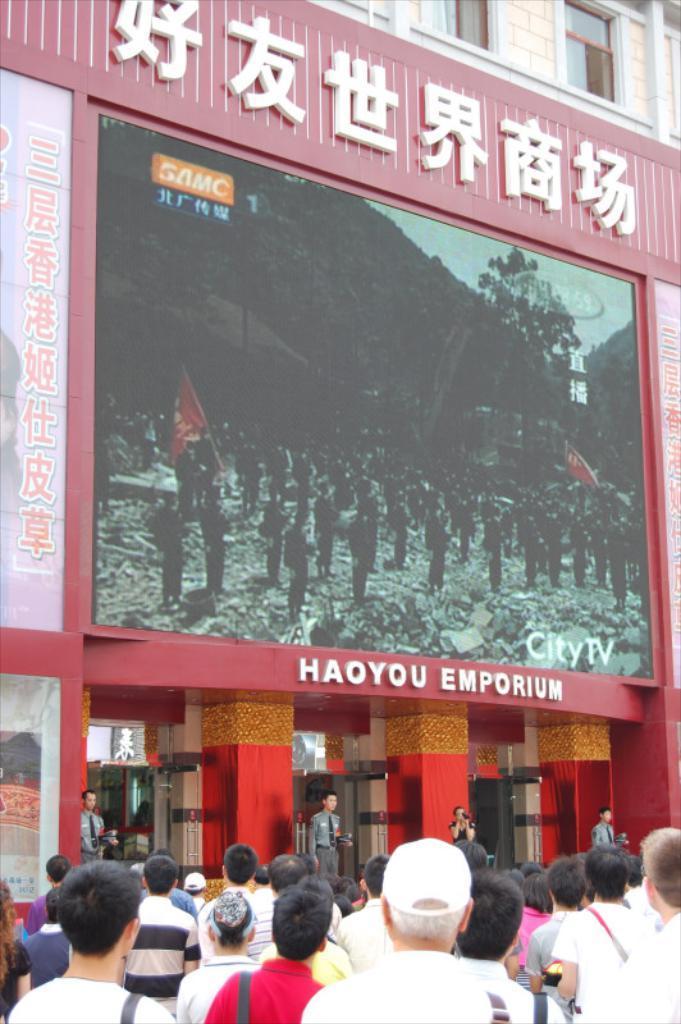Could you give a brief overview of what you see in this image? At the bottom we can see many peoples were watching the screen. In that screen we can see the soldiers were standing and some peoples are holding the flag. In the screen we can see the mountain, trees and sky. At the top we can see the building and windows. 